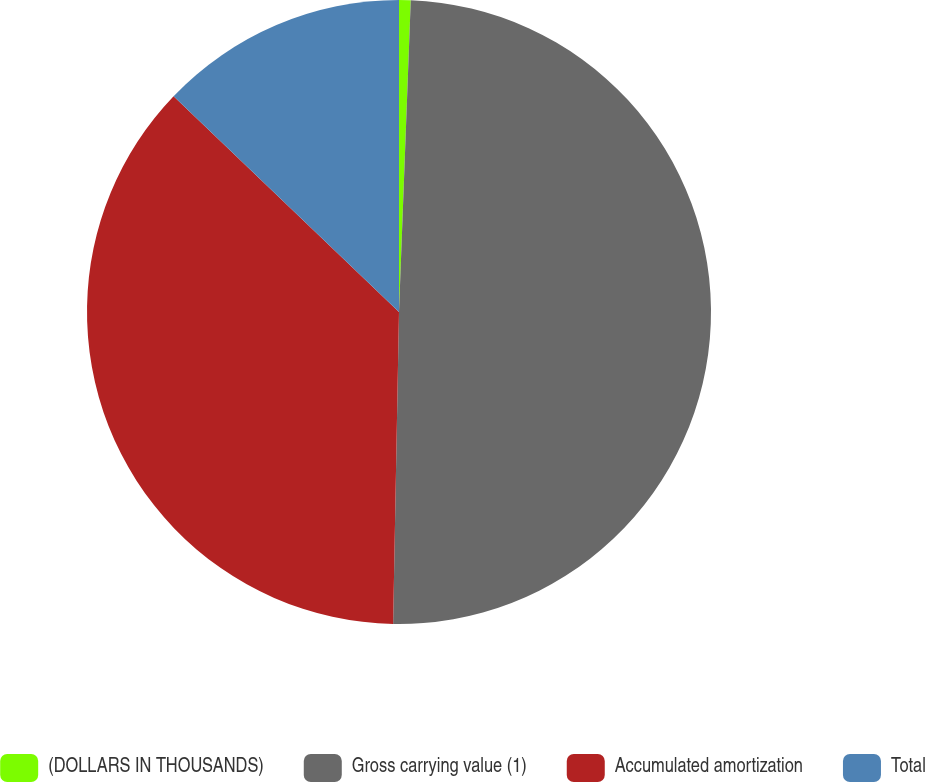<chart> <loc_0><loc_0><loc_500><loc_500><pie_chart><fcel>(DOLLARS IN THOUSANDS)<fcel>Gross carrying value (1)<fcel>Accumulated amortization<fcel>Total<nl><fcel>0.6%<fcel>49.7%<fcel>36.85%<fcel>12.85%<nl></chart> 